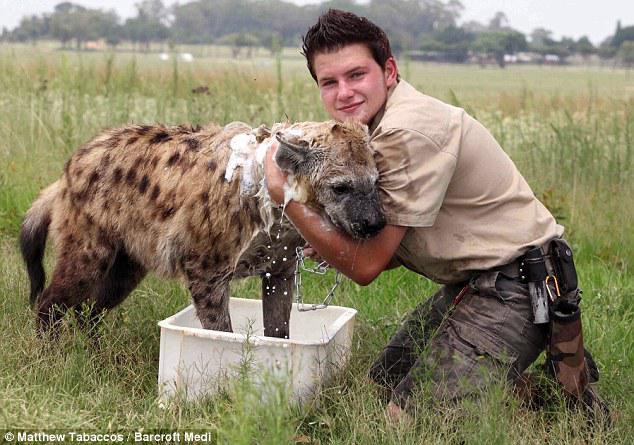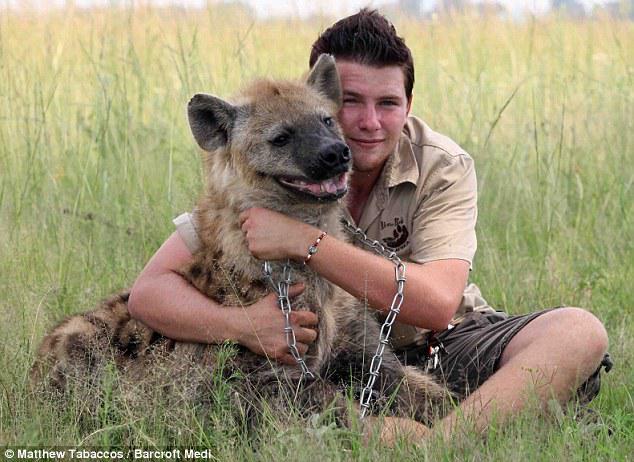The first image is the image on the left, the second image is the image on the right. Evaluate the accuracy of this statement regarding the images: "In at least one image, a man is hugging a hyena.". Is it true? Answer yes or no. Yes. The first image is the image on the left, the second image is the image on the right. For the images shown, is this caption "There are two men interacting with one or more large cats." true? Answer yes or no. Yes. 